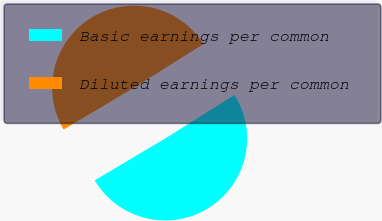Convert chart. <chart><loc_0><loc_0><loc_500><loc_500><pie_chart><fcel>Basic earnings per common<fcel>Diluted earnings per common<nl><fcel>50.39%<fcel>49.61%<nl></chart> 